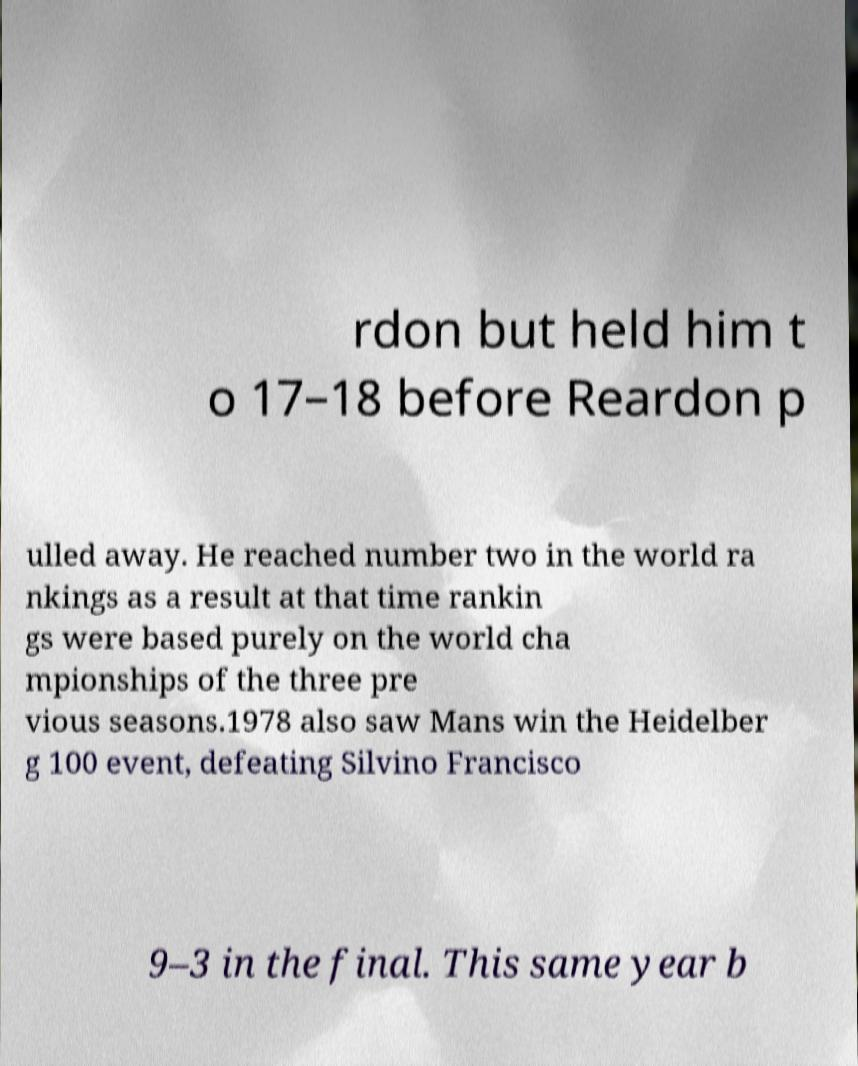Could you extract and type out the text from this image? rdon but held him t o 17–18 before Reardon p ulled away. He reached number two in the world ra nkings as a result at that time rankin gs were based purely on the world cha mpionships of the three pre vious seasons.1978 also saw Mans win the Heidelber g 100 event, defeating Silvino Francisco 9–3 in the final. This same year b 